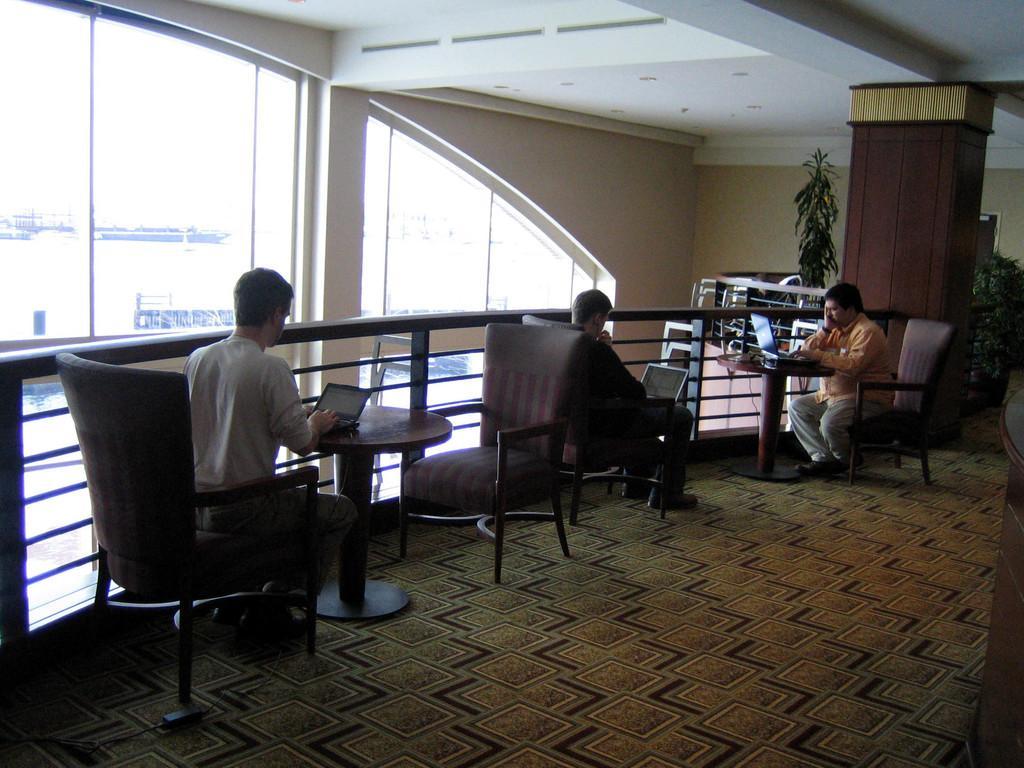How would you summarize this image in a sentence or two? inside the room there are so many table chairs are present and floor has trees are there and the three persons are sitting on the chair and they are doing something work on laptop and behind the person the big window is there 